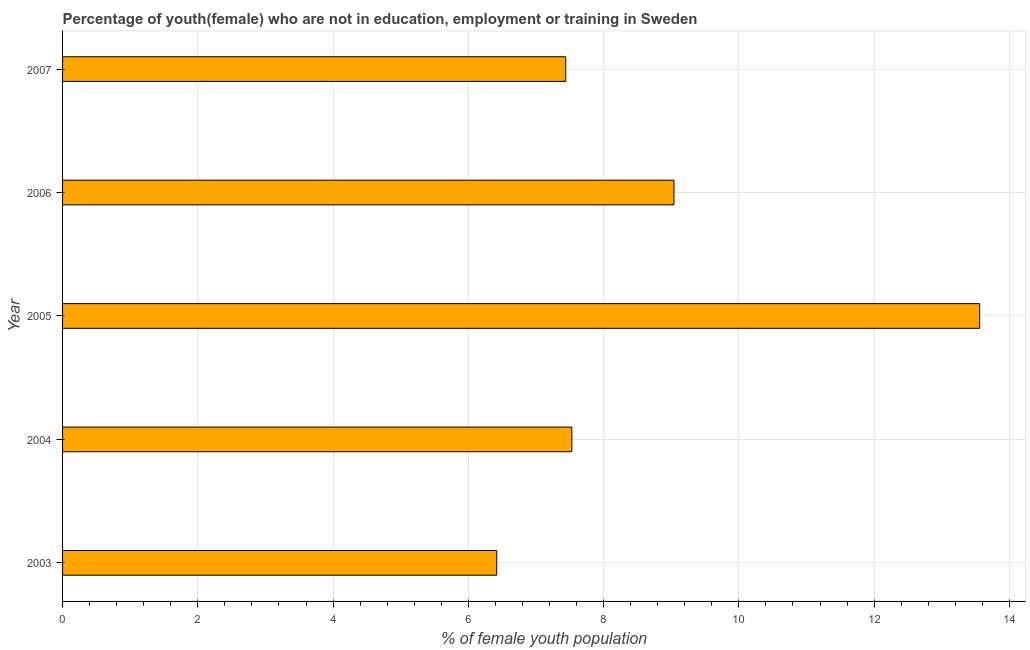Does the graph contain grids?
Your response must be concise. Yes. What is the title of the graph?
Keep it short and to the point. Percentage of youth(female) who are not in education, employment or training in Sweden. What is the label or title of the X-axis?
Give a very brief answer. % of female youth population. What is the unemployed female youth population in 2004?
Provide a succinct answer. 7.53. Across all years, what is the maximum unemployed female youth population?
Provide a short and direct response. 13.56. Across all years, what is the minimum unemployed female youth population?
Your response must be concise. 6.42. In which year was the unemployed female youth population maximum?
Provide a short and direct response. 2005. What is the sum of the unemployed female youth population?
Keep it short and to the point. 43.99. What is the difference between the unemployed female youth population in 2004 and 2005?
Offer a terse response. -6.03. What is the average unemployed female youth population per year?
Provide a succinct answer. 8.8. What is the median unemployed female youth population?
Offer a very short reply. 7.53. Do a majority of the years between 2003 and 2004 (inclusive) have unemployed female youth population greater than 2 %?
Your answer should be compact. Yes. What is the ratio of the unemployed female youth population in 2004 to that in 2006?
Offer a very short reply. 0.83. Is the unemployed female youth population in 2003 less than that in 2004?
Your answer should be very brief. Yes. Is the difference between the unemployed female youth population in 2004 and 2005 greater than the difference between any two years?
Provide a short and direct response. No. What is the difference between the highest and the second highest unemployed female youth population?
Your answer should be compact. 4.52. What is the difference between the highest and the lowest unemployed female youth population?
Your answer should be compact. 7.14. How many years are there in the graph?
Ensure brevity in your answer.  5. What is the difference between two consecutive major ticks on the X-axis?
Your response must be concise. 2. What is the % of female youth population in 2003?
Your response must be concise. 6.42. What is the % of female youth population of 2004?
Keep it short and to the point. 7.53. What is the % of female youth population in 2005?
Offer a very short reply. 13.56. What is the % of female youth population of 2006?
Your answer should be very brief. 9.04. What is the % of female youth population in 2007?
Keep it short and to the point. 7.44. What is the difference between the % of female youth population in 2003 and 2004?
Your answer should be very brief. -1.11. What is the difference between the % of female youth population in 2003 and 2005?
Make the answer very short. -7.14. What is the difference between the % of female youth population in 2003 and 2006?
Offer a terse response. -2.62. What is the difference between the % of female youth population in 2003 and 2007?
Offer a terse response. -1.02. What is the difference between the % of female youth population in 2004 and 2005?
Give a very brief answer. -6.03. What is the difference between the % of female youth population in 2004 and 2006?
Keep it short and to the point. -1.51. What is the difference between the % of female youth population in 2004 and 2007?
Make the answer very short. 0.09. What is the difference between the % of female youth population in 2005 and 2006?
Ensure brevity in your answer.  4.52. What is the difference between the % of female youth population in 2005 and 2007?
Offer a terse response. 6.12. What is the difference between the % of female youth population in 2006 and 2007?
Make the answer very short. 1.6. What is the ratio of the % of female youth population in 2003 to that in 2004?
Offer a very short reply. 0.85. What is the ratio of the % of female youth population in 2003 to that in 2005?
Provide a short and direct response. 0.47. What is the ratio of the % of female youth population in 2003 to that in 2006?
Offer a terse response. 0.71. What is the ratio of the % of female youth population in 2003 to that in 2007?
Your answer should be compact. 0.86. What is the ratio of the % of female youth population in 2004 to that in 2005?
Your answer should be compact. 0.56. What is the ratio of the % of female youth population in 2004 to that in 2006?
Your answer should be compact. 0.83. What is the ratio of the % of female youth population in 2005 to that in 2006?
Your response must be concise. 1.5. What is the ratio of the % of female youth population in 2005 to that in 2007?
Offer a terse response. 1.82. What is the ratio of the % of female youth population in 2006 to that in 2007?
Ensure brevity in your answer.  1.22. 